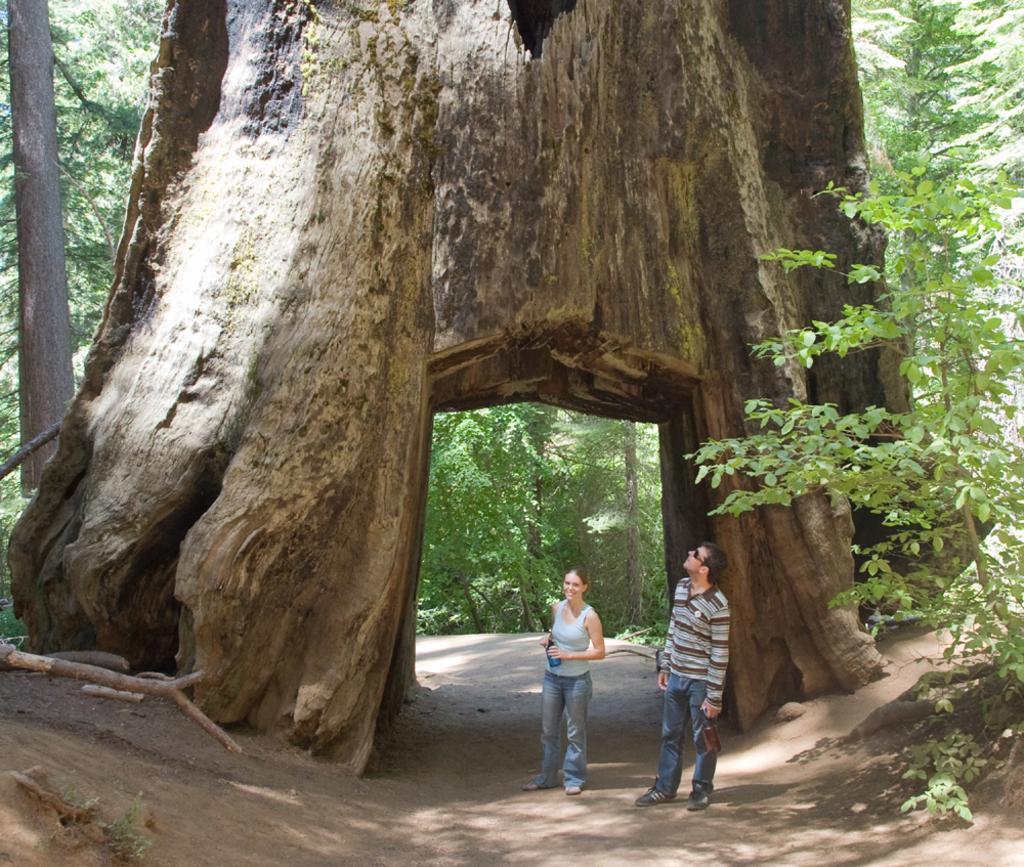Please provide a concise description of this image. In this picture there are two people standing and we can see trees and path. 